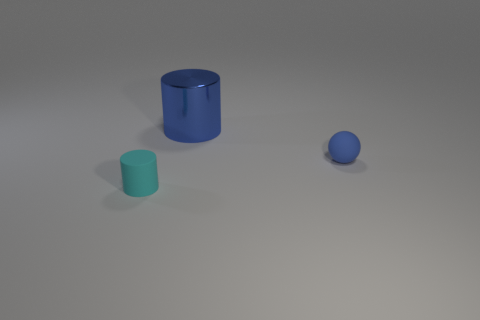What shape is the blue rubber thing that is the same size as the cyan matte thing?
Ensure brevity in your answer.  Sphere. Is there a rubber thing of the same shape as the shiny thing?
Your answer should be compact. Yes. Are there any blue things left of the tiny blue sphere behind the tiny thing that is in front of the tiny blue rubber ball?
Keep it short and to the point. Yes. Is the number of small matte things left of the blue matte ball greater than the number of small matte cylinders behind the big metallic cylinder?
Provide a succinct answer. Yes. There is a blue sphere that is the same size as the cyan rubber object; what material is it?
Provide a succinct answer. Rubber. How many small objects are cyan cylinders or red matte cubes?
Keep it short and to the point. 1. Does the cyan object have the same shape as the blue metallic object?
Provide a short and direct response. Yes. What number of things are on the left side of the matte ball and right of the cyan object?
Provide a short and direct response. 1. Is there any other thing that is the same color as the small rubber cylinder?
Provide a succinct answer. No. There is a tiny cyan object that is the same material as the blue ball; what is its shape?
Give a very brief answer. Cylinder. 